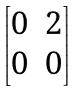<formula> <loc_0><loc_0><loc_500><loc_500>\begin{bmatrix} 0 & 2 \\ 0 & 0 \end{bmatrix}</formula> 